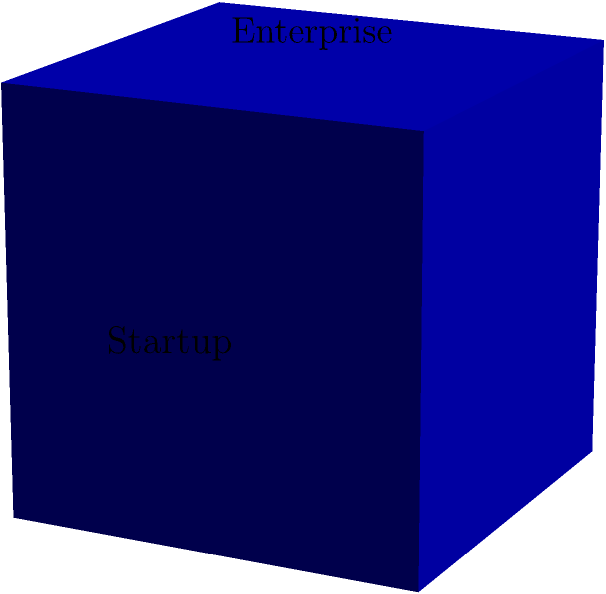A cube represents different customer segments in your portfolio. The surface area of the "Enterprise" face is 64 square units. If the total surface area of the cube is 384 square units, what is the length of an edge of the cube? How does this relate to the concept of balanced customer segmentation in customer success management? Let's approach this step-by-step:

1) First, we need to understand the relationship between the surface area of one face and the total surface area of a cube.

2) Let $x$ be the length of an edge of the cube.

3) The area of one face (the "Enterprise" face) is given as 64 square units. So:
   $x^2 = 64$

4) The total surface area of a cube is given by the formula $6x^2$, where $x$ is the length of an edge.

5) We're told that the total surface area is 384 square units. So:
   $6x^2 = 384$

6) From step 3, we can find $x$:
   $x = \sqrt{64} = 8$

7) We can verify this using the total surface area:
   $6 * 8^2 = 6 * 64 = 384$, which matches our given total.

In customer success management, this cube model can represent a balanced approach to customer segmentation. Each face of the cube represents a different customer segment (Enterprise, SMB, Startup), and the equal edge lengths suggest that equal attention and resources should be allocated to each segment. However, the specific needs and strategies for each segment may differ, just as each face of the cube has a different orientation despite having the same area.
Answer: 8 units 